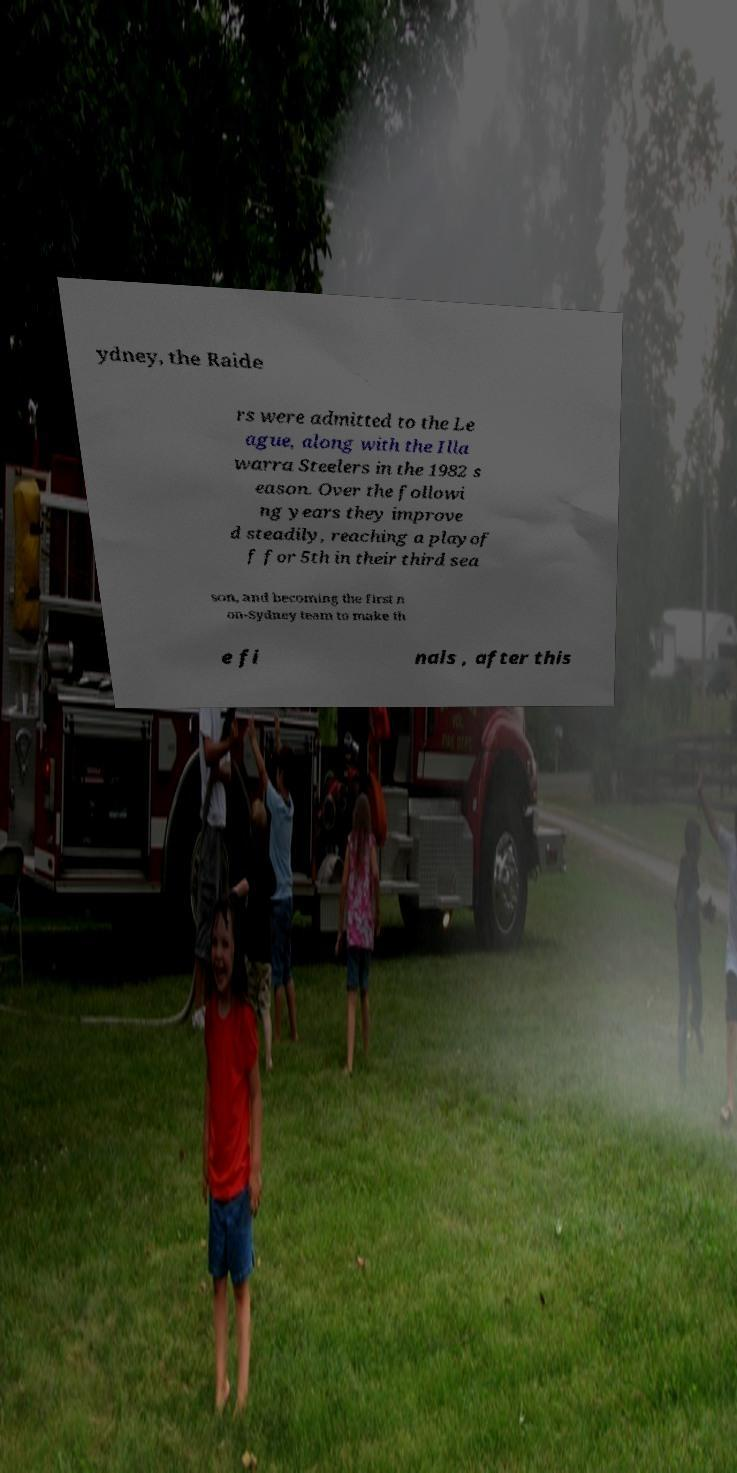For documentation purposes, I need the text within this image transcribed. Could you provide that? ydney, the Raide rs were admitted to the Le ague, along with the Illa warra Steelers in the 1982 s eason. Over the followi ng years they improve d steadily, reaching a playof f for 5th in their third sea son, and becoming the first n on-Sydney team to make th e fi nals , after this 